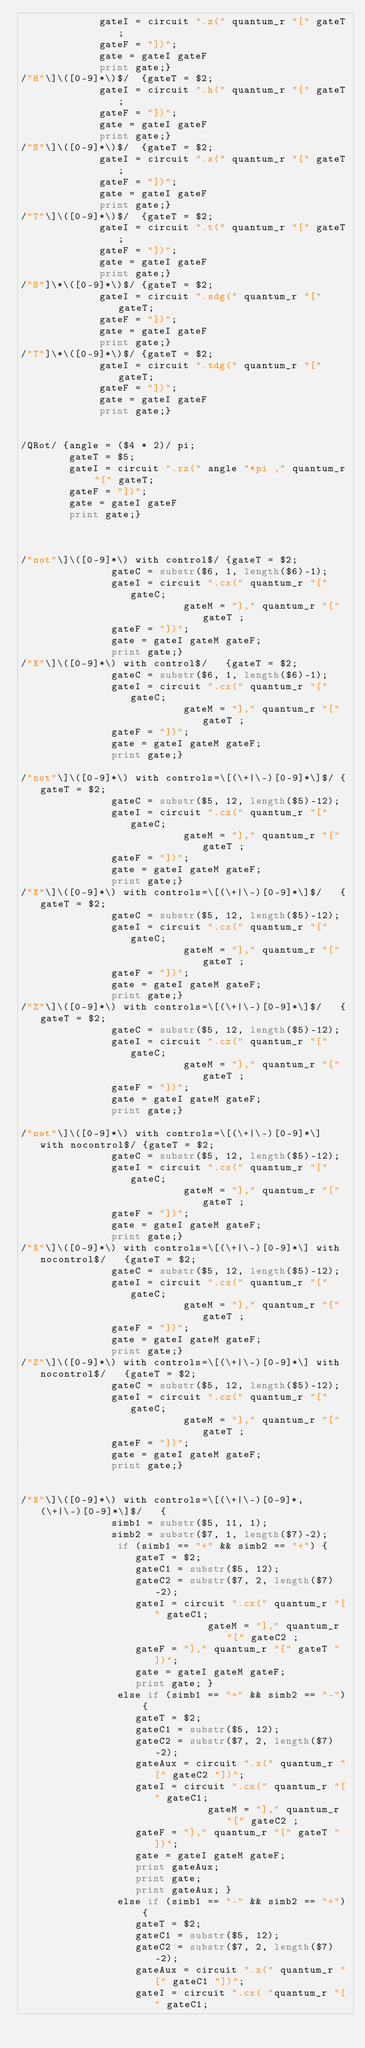Convert code to text. <code><loc_0><loc_0><loc_500><loc_500><_Awk_>			 gateI = circuit ".z(" quantum_r "[" gateT;
			 gateF = "])";
			 gate = gateI gateF
			 print gate;}
/"H"\]\([0-9]*\)$/	{gateT = $2;
			 gateI = circuit ".h(" quantum_r "[" gateT;
			 gateF = "])";
			 gate = gateI gateF
			 print gate;}
/"S"\]\([0-9]*\)$/	{gateT = $2;
			 gateI = circuit ".s(" quantum_r "[" gateT;
			 gateF = "])";
			 gate = gateI gateF
			 print gate;}
/"T"\]\([0-9]*\)$/	{gateT = $2;
			 gateI = circuit ".t(" quantum_r "[" gateT;
			 gateF = "])";
			 gate = gateI gateF
			 print gate;}
/"S"]\*\([0-9]*\)$/ {gateT = $2;
			 gateI = circuit ".sdg(" quantum_r "[" gateT;
			 gateF = "])";
			 gate = gateI gateF
			 print gate;}
/"T"]\*\([0-9]*\)$/ {gateT = $2;
			 gateI = circuit ".tdg(" quantum_r "[" gateT;
			 gateF = "])";
			 gate = gateI gateF
			 print gate;}


/QRot/ {angle = ($4 * 2)/ pi;
		gateT = $5;
	    gateI = circuit ".rz(" angle "*pi ," quantum_r "[" gateT;
		gateF = "])";
		gate = gateI gateF
		print gate;}



/"not"\]\([0-9]*\) with control$/ {gateT = $2;
			   gateC = substr($6, 1, length($6)-1);
			   gateI = circuit ".cx(" quantum_r "[" gateC;
                           gateM = "]," quantum_r "[" gateT ;
			   gateF = "])";
			   gate = gateI gateM gateF;
			   print gate;}
/"X"\]\([0-9]*\) with control$/   {gateT = $2;
			   gateC = substr($6, 1, length($6)-1);
			   gateI = circuit ".cx(" quantum_r "[" gateC;
                           gateM = "]," quantum_r "[" gateT ;
			   gateF = "])";
			   gate = gateI gateM gateF;
			   print gate;}

/"not"\]\([0-9]*\) with controls=\[(\+|\-)[0-9]*\]$/ {gateT = $2;
			   gateC = substr($5, 12, length($5)-12); 
			   gateI = circuit ".cx(" quantum_r "[" gateC;
                           gateM = "]," quantum_r "[" gateT ;
			   gateF = "])";
			   gate = gateI gateM gateF;
			   print gate;}
/"X"\]\([0-9]*\) with controls=\[(\+|\-)[0-9]*\]$/   {gateT = $2;
			   gateC = substr($5, 12, length($5)-12);
			   gateI = circuit ".cx(" quantum_r "[" gateC;
                           gateM = "]," quantum_r "[" gateT ;
			   gateF = "])";
			   gate = gateI gateM gateF;
			   print gate;}
/"Z"\]\([0-9]*\) with controls=\[(\+|\-)[0-9]*\]$/   {gateT = $2;
			   gateC = substr($5, 12, length($5)-12);
			   gateI = circuit ".cz(" quantum_r "[" gateC;
                           gateM = "]," quantum_r "[" gateT ;
			   gateF = "])";
			   gate = gateI gateM gateF;
			   print gate;}

/"not"\]\([0-9]*\) with controls=\[(\+|\-)[0-9]*\] with nocontrol$/ {gateT = $2;
			   gateC = substr($5, 12, length($5)-12);
			   gateI = circuit ".cx(" quantum_r "[" gateC;
                           gateM = "]," quantum_r "[" gateT ;
			   gateF = "])";
			   gate = gateI gateM gateF;
			   print gate;}
/"X"\]\([0-9]*\) with controls=\[(\+|\-)[0-9]*\] with nocontrol$/   {gateT = $2;
			   gateC = substr($5, 12, length($5)-12);
			   gateI = circuit ".cx(" quantum_r "[" gateC;
                           gateM = "]," quantum_r "[" gateT ;
			   gateF = "])";
			   gate = gateI gateM gateF;
			   print gate;}
/"Z"\]\([0-9]*\) with controls=\[(\+|\-)[0-9]*\] with nocontrol$/   {gateT = $2;
			   gateC = substr($5, 12, length($5)-12);
			   gateI = circuit ".cz(" quantum_r "[" gateC;
                           gateM = "]," quantum_r "[" gateT ;
			   gateF = "])";
			   gate = gateI gateM gateF;
			   print gate;}


/"X"\]\([0-9]*\) with controls=\[(\+|\-)[0-9]*, (\+|\-)[0-9]*\]$/   {
			   simb1 = substr($5, 11, 1);
			   simb2 = substr($7, 1, length($7)-2);
				if (simb1 == "+" && simb2 == "+") {
				   gateT = $2;
				   gateC1 = substr($5, 12);
				   gateC2 = substr($7, 2, length($7)-2);
				   gateI = circuit ".cx(" quantum_r "[" gateC1;
        	                   gateM = "]," quantum_r "[" gateC2 ;
				   gateF = "]," quantum_r "[" gateT "])";
				   gate = gateI gateM gateF;
				   print gate; }
				else if (simb1 == "+" && simb2 == "-") {
				   gateT = $2;
				   gateC1 = substr($5, 12);
				   gateC2 = substr($7, 2, length($7)-2);
				   gateAux = circuit ".x(" quantum_r "[" gateC2 "])";
				   gateI = circuit ".cx(" quantum_r "[" gateC1;
        	                   gateM = "]," quantum_r "[" gateC2 ;
				   gateF = "]," quantum_r "[" gateT "])";
				   gate = gateI gateM gateF;
				   print gateAux;
				   print gate;
                   print gateAux; }
				else if (simb1 == "-" && simb2 == "+") {
				   gateT = $2;
				   gateC1 = substr($5, 12);
				   gateC2 = substr($7, 2, length($7)-2);
				   gateAux = circuit ".x(" quantum_r "[" gateC1 "])";
				   gateI = circuit ".cx( "quantum_r "[" gateC1;</code> 